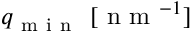<formula> <loc_0><loc_0><loc_500><loc_500>q _ { m i n } \ [ n m ^ { - 1 } ]</formula> 